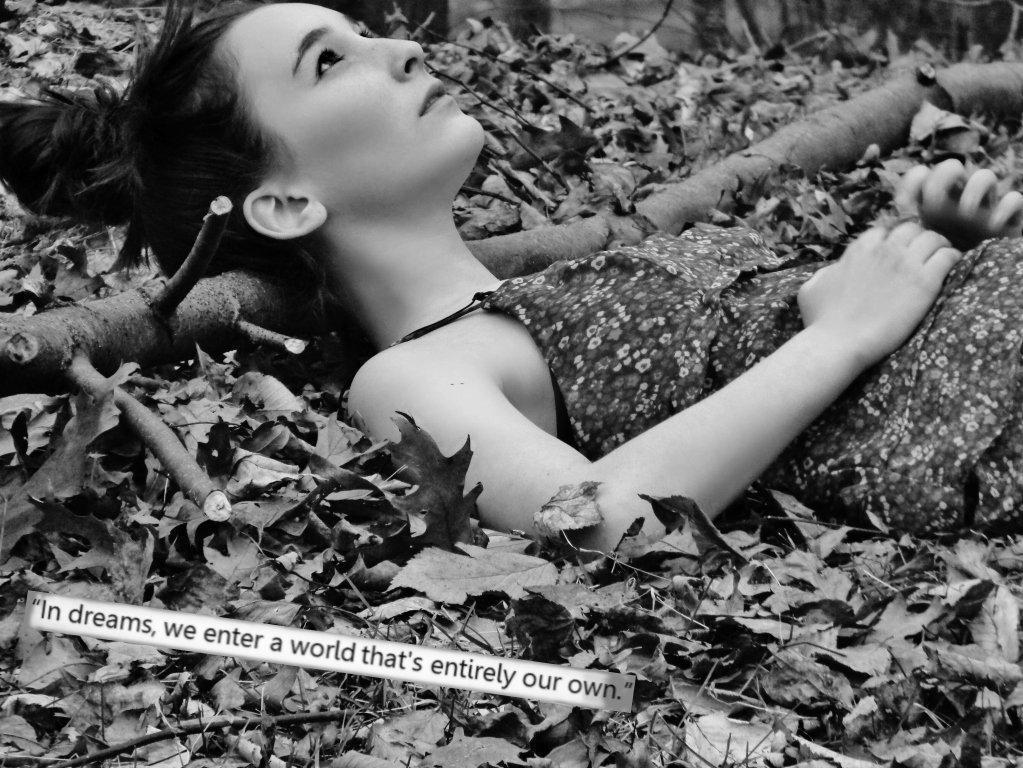Describe this image in one or two sentences. This is a black and white picture. In this picture there are dry leaves, twigs, wooden log and a woman lying. At the bottom there is text. The background is blurred. 